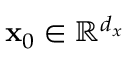<formula> <loc_0><loc_0><loc_500><loc_500>x _ { 0 } \in \mathbb { R } ^ { d _ { x } }</formula> 